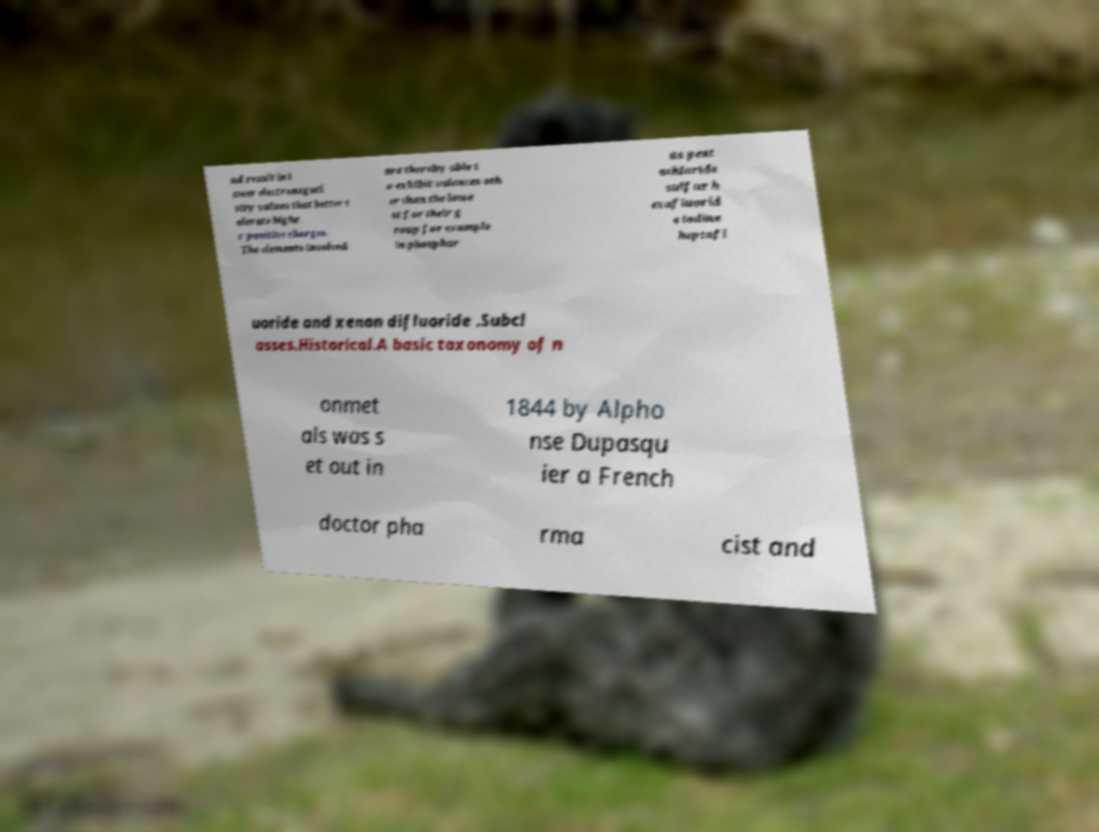Can you read and provide the text displayed in the image?This photo seems to have some interesting text. Can you extract and type it out for me? nd result in l ower electronegati vity values that better t olerate highe r positive charges. The elements involved are thereby able t o exhibit valences oth er than the lowe st for their g roup for example in phosphor us pent achloride sulfur h exafluorid e iodine heptafl uoride and xenon difluoride .Subcl asses.Historical.A basic taxonomy of n onmet als was s et out in 1844 by Alpho nse Dupasqu ier a French doctor pha rma cist and 